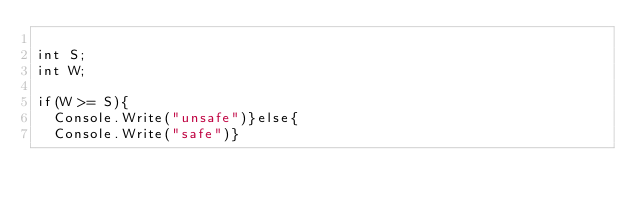Convert code to text. <code><loc_0><loc_0><loc_500><loc_500><_C#_>
int S;
int W;

if(W >= S){
  Console.Write("unsafe")}else{
  Console.Write("safe")}</code> 